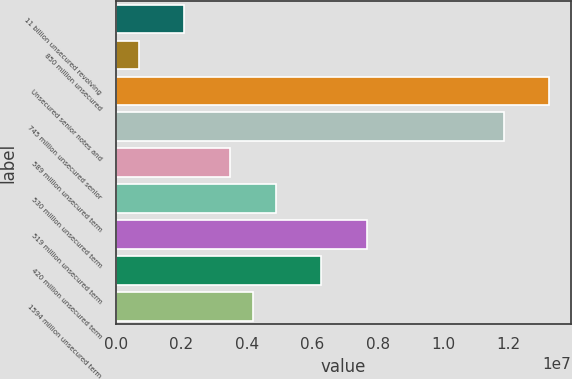Convert chart. <chart><loc_0><loc_0><loc_500><loc_500><bar_chart><fcel>11 billion unsecured revolving<fcel>850 million unsecured<fcel>Unsecured senior notes and<fcel>745 million unsecured senior<fcel>589 million unsecured term<fcel>530 million unsecured term<fcel>519 million unsecured term<fcel>420 million unsecured term<fcel>1594 million unsecured term<nl><fcel>2.09525e+06<fcel>702327<fcel>1.32386e+07<fcel>1.18457e+07<fcel>3.48817e+06<fcel>4.88108e+06<fcel>7.66692e+06<fcel>6.274e+06<fcel>4.18463e+06<nl></chart> 